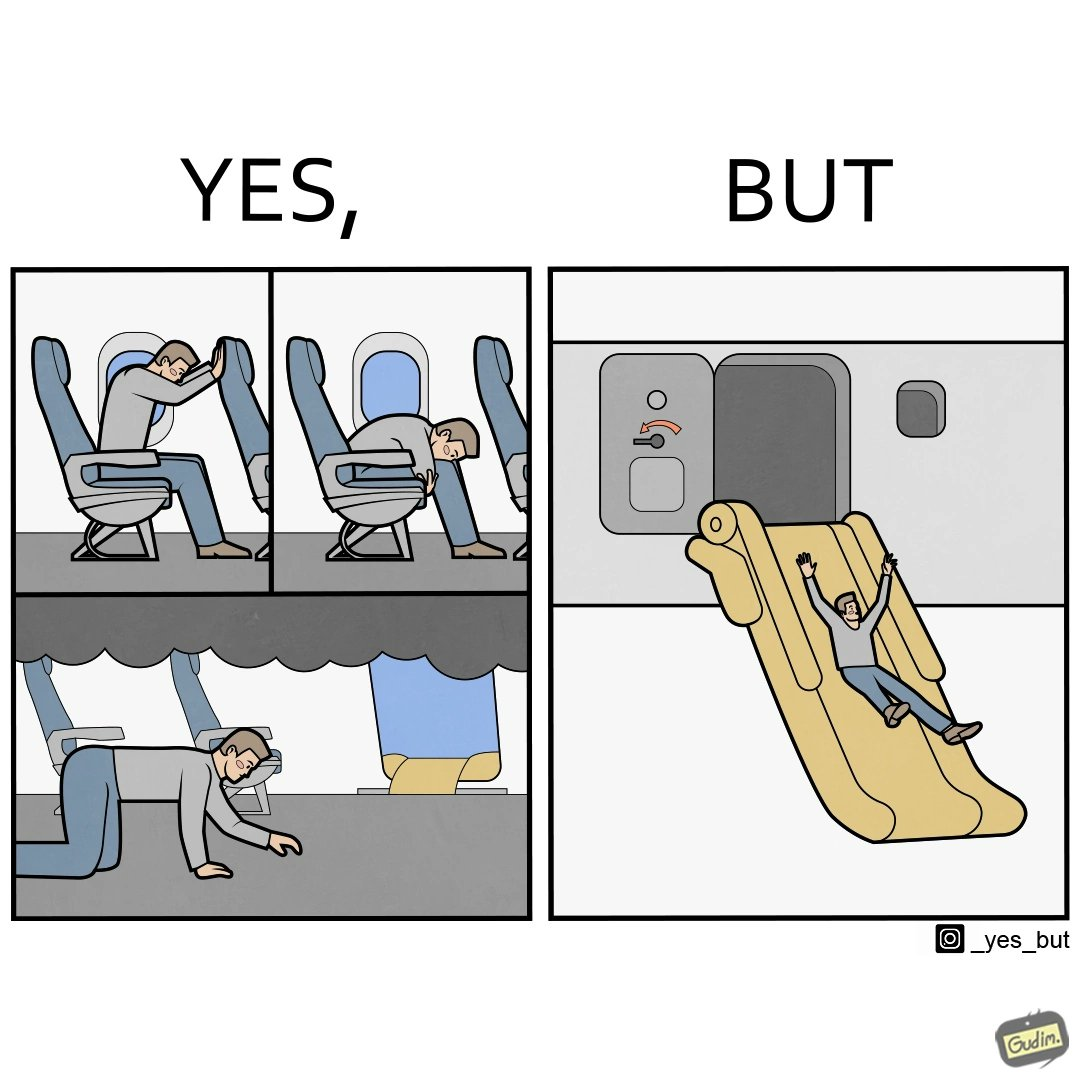Is this a satirical image? Yes, this image is satirical. 